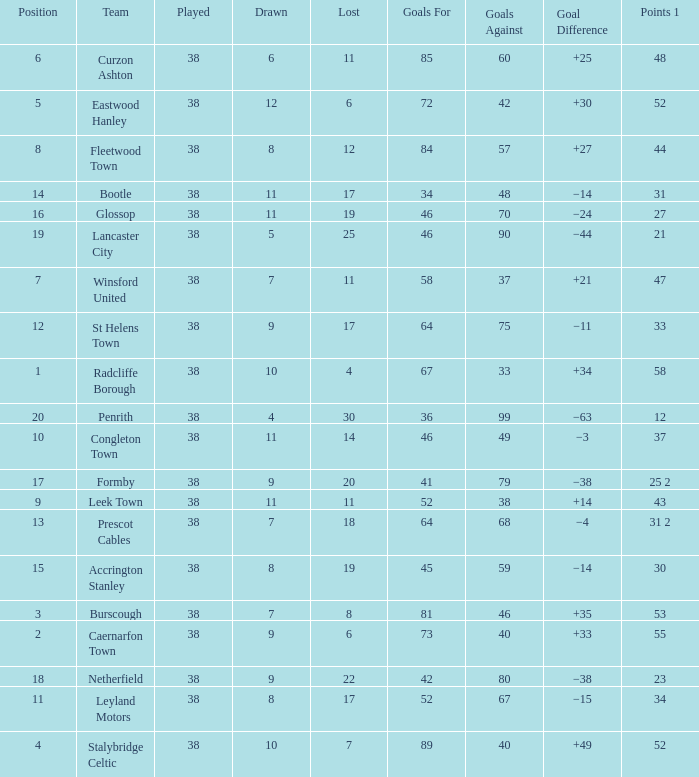WHAT IS THE SUM PLAYED WITH POINTS 1 OF 53, AND POSITION LARGER THAN 3? None. 